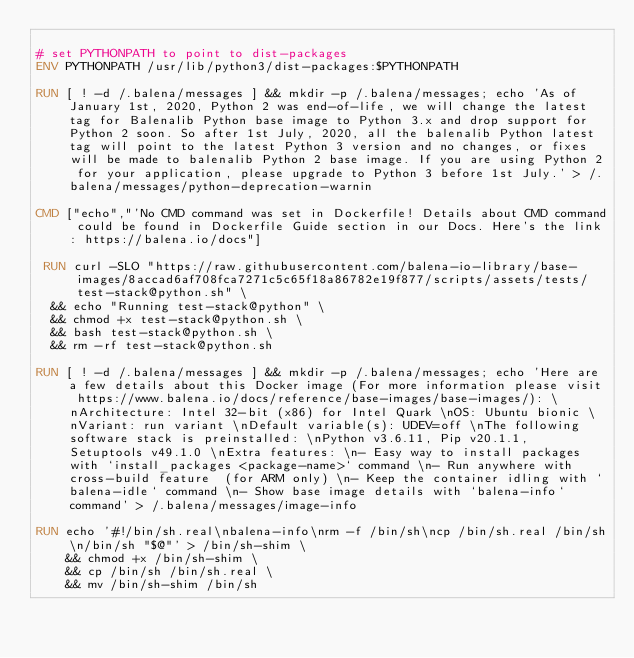<code> <loc_0><loc_0><loc_500><loc_500><_Dockerfile_>
# set PYTHONPATH to point to dist-packages
ENV PYTHONPATH /usr/lib/python3/dist-packages:$PYTHONPATH

RUN [ ! -d /.balena/messages ] && mkdir -p /.balena/messages; echo 'As of January 1st, 2020, Python 2 was end-of-life, we will change the latest tag for Balenalib Python base image to Python 3.x and drop support for Python 2 soon. So after 1st July, 2020, all the balenalib Python latest tag will point to the latest Python 3 version and no changes, or fixes will be made to balenalib Python 2 base image. If you are using Python 2 for your application, please upgrade to Python 3 before 1st July.' > /.balena/messages/python-deprecation-warnin

CMD ["echo","'No CMD command was set in Dockerfile! Details about CMD command could be found in Dockerfile Guide section in our Docs. Here's the link: https://balena.io/docs"]

 RUN curl -SLO "https://raw.githubusercontent.com/balena-io-library/base-images/8accad6af708fca7271c5c65f18a86782e19f877/scripts/assets/tests/test-stack@python.sh" \
  && echo "Running test-stack@python" \
  && chmod +x test-stack@python.sh \
  && bash test-stack@python.sh \
  && rm -rf test-stack@python.sh 

RUN [ ! -d /.balena/messages ] && mkdir -p /.balena/messages; echo 'Here are a few details about this Docker image (For more information please visit https://www.balena.io/docs/reference/base-images/base-images/): \nArchitecture: Intel 32-bit (x86) for Intel Quark \nOS: Ubuntu bionic \nVariant: run variant \nDefault variable(s): UDEV=off \nThe following software stack is preinstalled: \nPython v3.6.11, Pip v20.1.1, Setuptools v49.1.0 \nExtra features: \n- Easy way to install packages with `install_packages <package-name>` command \n- Run anywhere with cross-build feature  (for ARM only) \n- Keep the container idling with `balena-idle` command \n- Show base image details with `balena-info` command' > /.balena/messages/image-info

RUN echo '#!/bin/sh.real\nbalena-info\nrm -f /bin/sh\ncp /bin/sh.real /bin/sh\n/bin/sh "$@"' > /bin/sh-shim \
	&& chmod +x /bin/sh-shim \
	&& cp /bin/sh /bin/sh.real \
	&& mv /bin/sh-shim /bin/sh</code> 